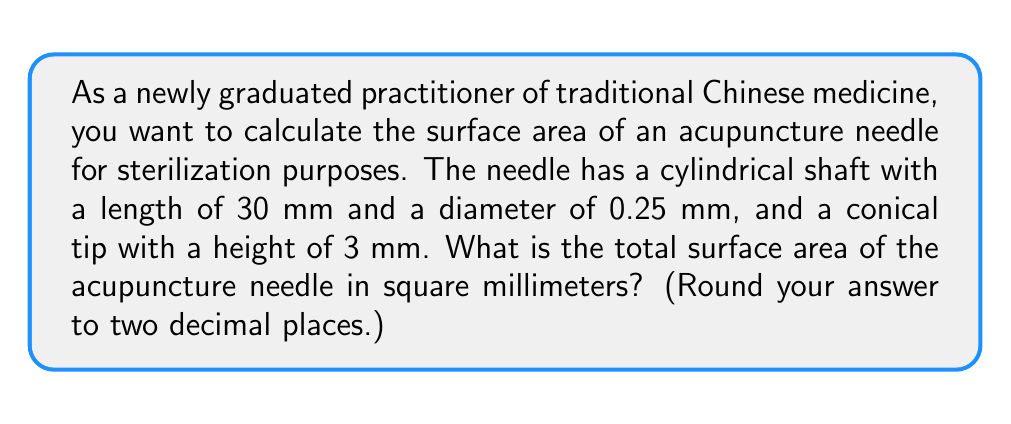Solve this math problem. To find the total surface area of the acupuncture needle, we need to calculate the surface area of the cylindrical shaft and the conical tip separately, then add them together.

1. Surface area of the cylindrical shaft:
   - Lateral surface area of a cylinder: $A_{cylinder} = \pi d h$
   - where $d$ is the diameter and $h$ is the height (length) of the cylinder
   - $A_{cylinder} = \pi (0.25 \text{ mm}) (30 \text{ mm}) = 23.56 \text{ mm}^2$

2. Surface area of the conical tip:
   - Surface area of a cone: $A_{cone} = \pi r s$
   - where $r$ is the radius of the base and $s$ is the slant height
   - Radius of the base: $r = 0.125 \text{ mm}$ (half the diameter)
   - To find the slant height, we use the Pythagorean theorem:
     $s = \sqrt{h^2 + r^2} = \sqrt{3^2 + 0.125^2} = 3.003 \text{ mm}$
   - $A_{cone} = \pi (0.125 \text{ mm}) (3.003 \text{ mm}) = 1.18 \text{ mm}^2$

3. Total surface area:
   $A_{total} = A_{cylinder} + A_{cone} = 23.56 \text{ mm}^2 + 1.18 \text{ mm}^2 = 24.74 \text{ mm}^2$

Rounding to two decimal places, we get 24.74 mm².
Answer: 24.74 mm² 